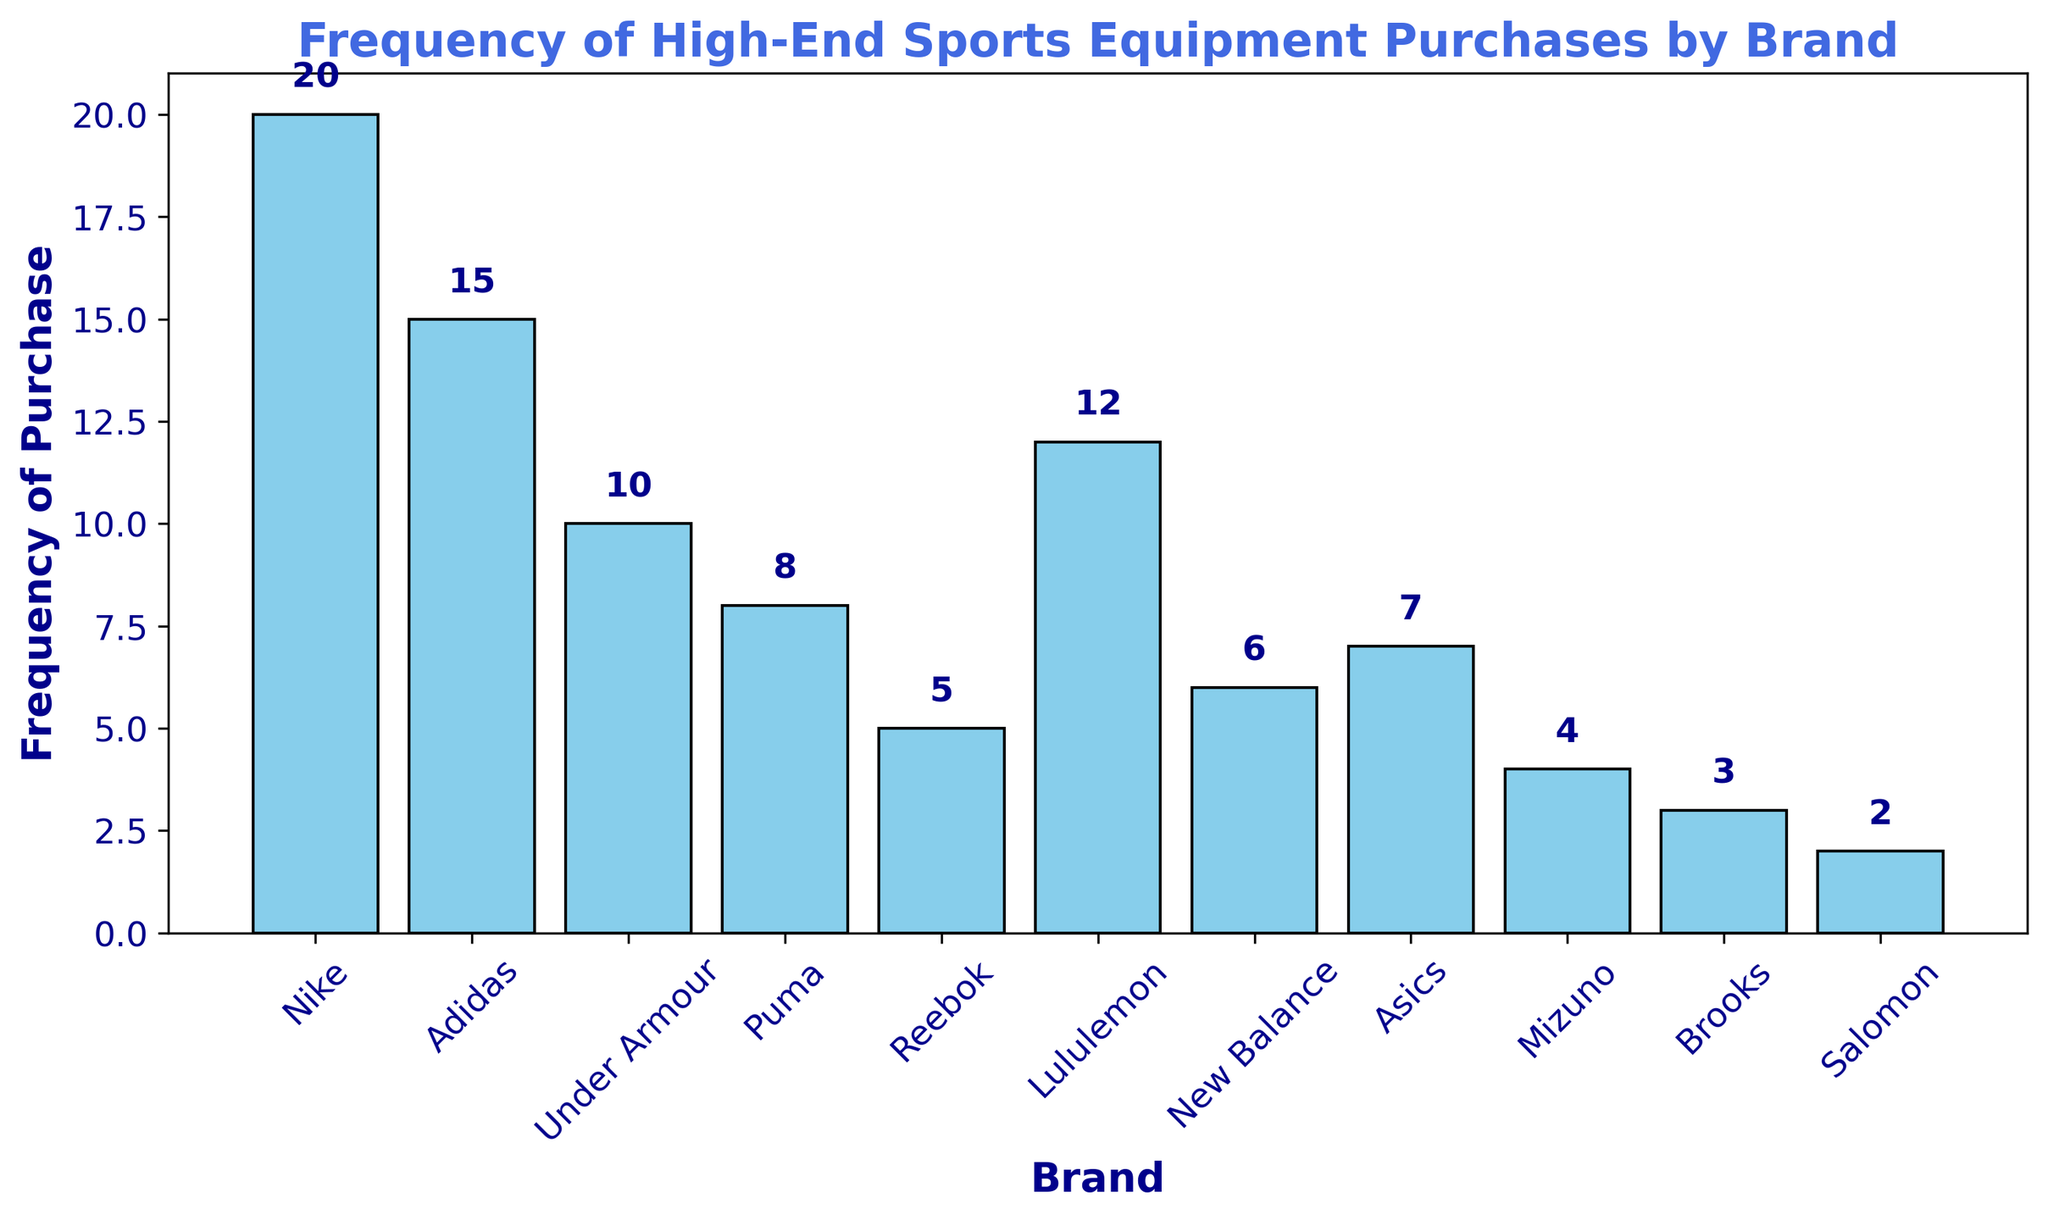What's the most frequently purchased brand? By looking at the bar heights, the tallest bar represents Nike with a frequency of 20, indicating it is the most frequently purchased brand.
Answer: Nike Which brand has a lower frequency of purchases, Puma or Asics? By comparing the heights of the bars for Puma and Asics, Puma has a frequency of 8, and Asics has a frequency of 7. Therefore, Asics has a lower frequency.
Answer: Asics What's the total frequency of purchases for the top three brands combined? The top three brands by frequency are Nike (20), Adidas (15), and Lululemon (12). Adding these frequencies together: 20 + 15 + 12 = 47.
Answer: 47 Which brand has a frequency twice that of Brooks? Brooks has a frequency of 3. The brand with a frequency twice that is 3 * 2 = 6, which is New Balance.
Answer: New Balance Is the frequency of purchases for Under Armour greater than the combined frequency for Reebok and Brooks? Under Armour has a frequency of 10. Reebok and Brooks together have a frequency of 5 + 3 = 8. Since 10 is greater than 8, Under Armour's frequency is greater.
Answer: Yes How many brands have a purchase frequency less than 10? Counting the brands with frequencies less than 10: Puma (8), Reebok (5), New Balance (6), Asics (7), Mizuno (4), and Brooks (3), Salomon (2). There are 7 such brands.
Answer: 7 What is the difference in purchase frequency between Nike and Adidas? Nike's frequency is 20, Adidas' frequency is 15. The difference is 20 - 15 = 5.
Answer: 5 What's the average purchase frequency of all brands shown in the histogram? Summing all frequencies: 20 + 15 + 10 + 8 + 5 + 12 + 6 + 7 + 4 + 3 + 2 = 92. There are 11 brands. The average is 92 / 11 ≈ 8.36.
Answer: 8.36 Which brand has the smallest purchase frequency? The smallest bar height represents Salomon with a frequency of 2, indicating it is the least purchased brand.
Answer: Salomon 